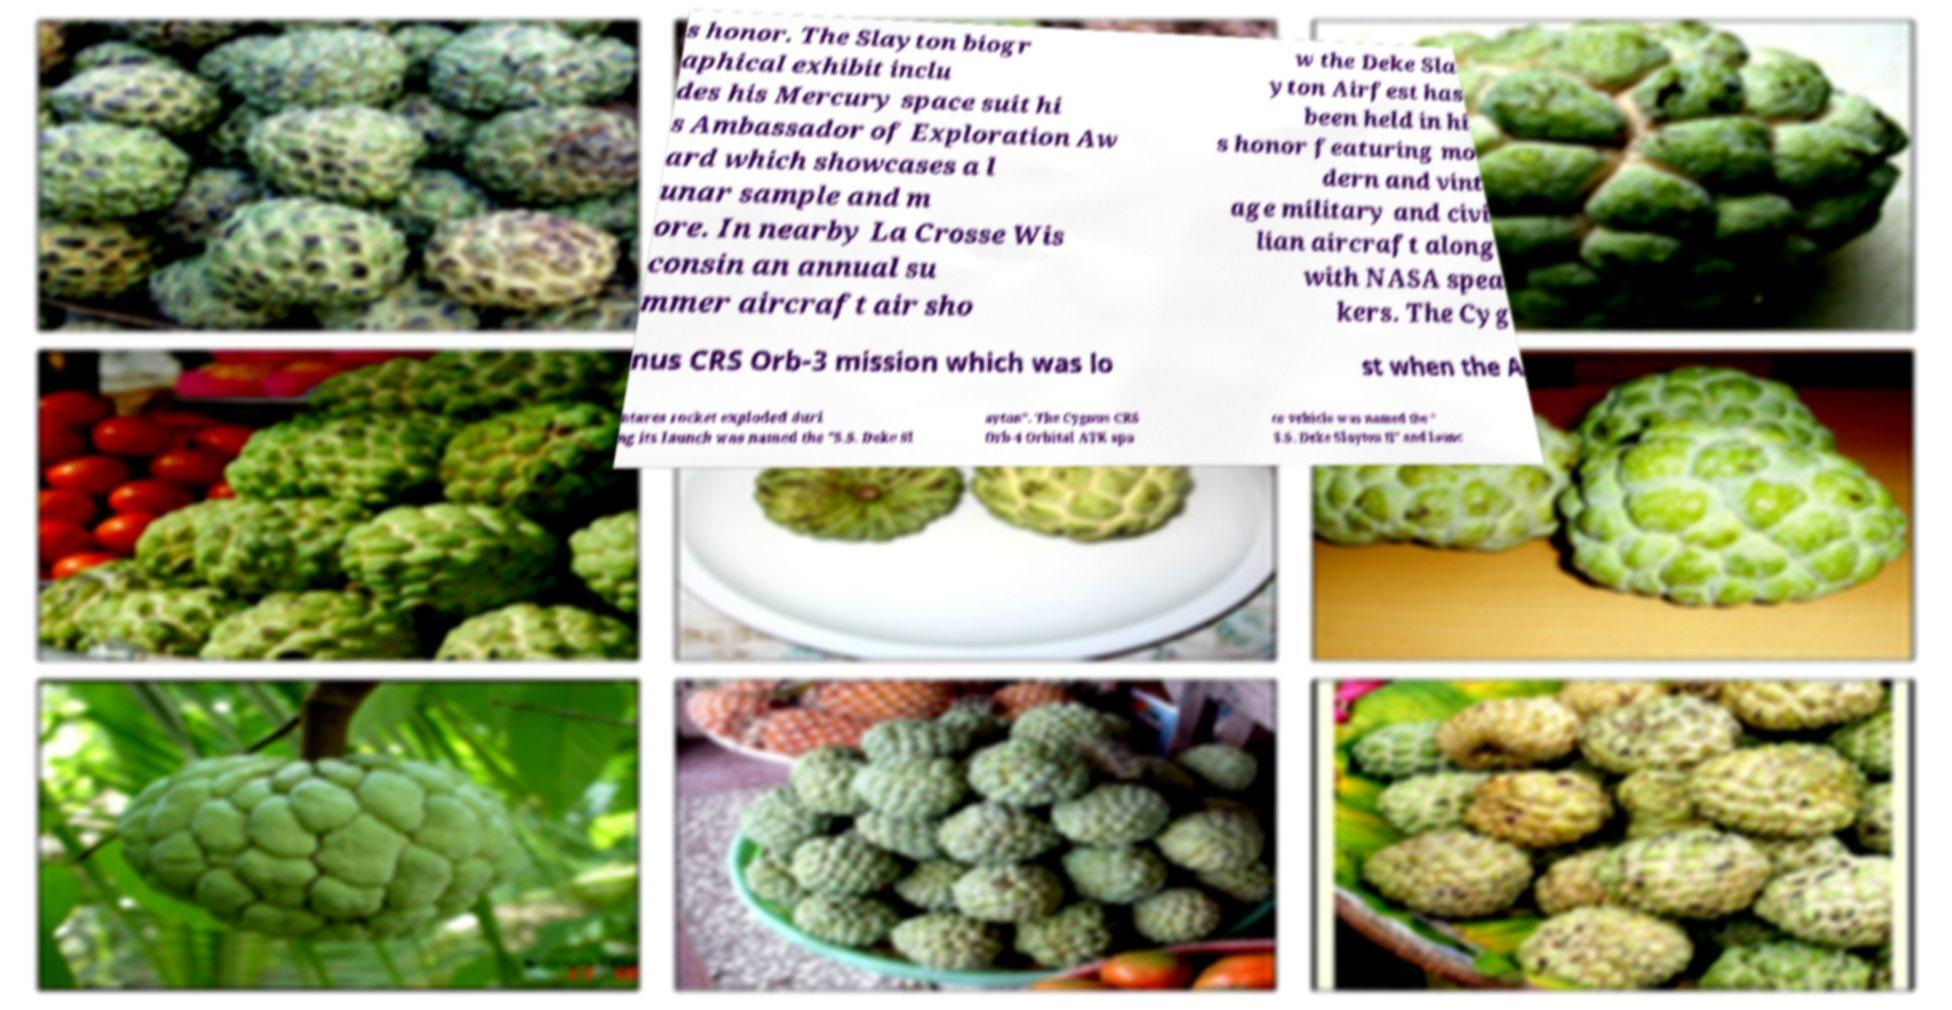Could you extract and type out the text from this image? s honor. The Slayton biogr aphical exhibit inclu des his Mercury space suit hi s Ambassador of Exploration Aw ard which showcases a l unar sample and m ore. In nearby La Crosse Wis consin an annual su mmer aircraft air sho w the Deke Sla yton Airfest has been held in hi s honor featuring mo dern and vint age military and civi lian aircraft along with NASA spea kers. The Cyg nus CRS Orb-3 mission which was lo st when the A ntares rocket exploded duri ng its launch was named the "S.S. Deke Sl ayton". The Cygnus CRS Orb-4 Orbital ATK spa ce vehicle was named the " S.S. Deke Slayton II" and launc 